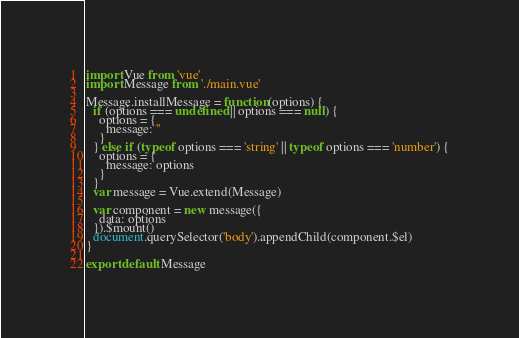<code> <loc_0><loc_0><loc_500><loc_500><_JavaScript_>import Vue from 'vue'
import Message from './main.vue'

Message.installMessage = function(options) {
  if (options === undefined || options === null) {
    options = {
      message: ''
    }
  } else if (typeof options === 'string' || typeof options === 'number') {
    options = {
      message: options
    }
  }
  var message = Vue.extend(Message)

  var component = new message({
    data: options
  }).$mount()
  document.querySelector('body').appendChild(component.$el)
}

export default Message</code> 